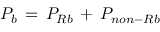<formula> <loc_0><loc_0><loc_500><loc_500>P _ { b } \, = \, P _ { R b } \, + \, P _ { n o n - R b }</formula> 